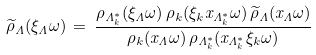Convert formula to latex. <formula><loc_0><loc_0><loc_500><loc_500>\widetilde { \rho } _ { \Lambda } ( \xi _ { \Lambda } \omega ) \, = \, \frac { \rho _ { \Lambda _ { k } ^ { * } } ( \xi _ { \Lambda } \omega ) \, \rho _ { k } ( \xi _ { k } x _ { \Lambda _ { k } ^ { * } } \omega ) \, \widetilde { \rho } _ { \Lambda } ( x _ { \Lambda } \omega ) } { \rho _ { k } ( x _ { \Lambda } \omega ) \, \rho _ { \Lambda _ { k } ^ { * } } ( x _ { \Lambda _ { k } ^ { * } } \xi _ { k } \omega ) }</formula> 